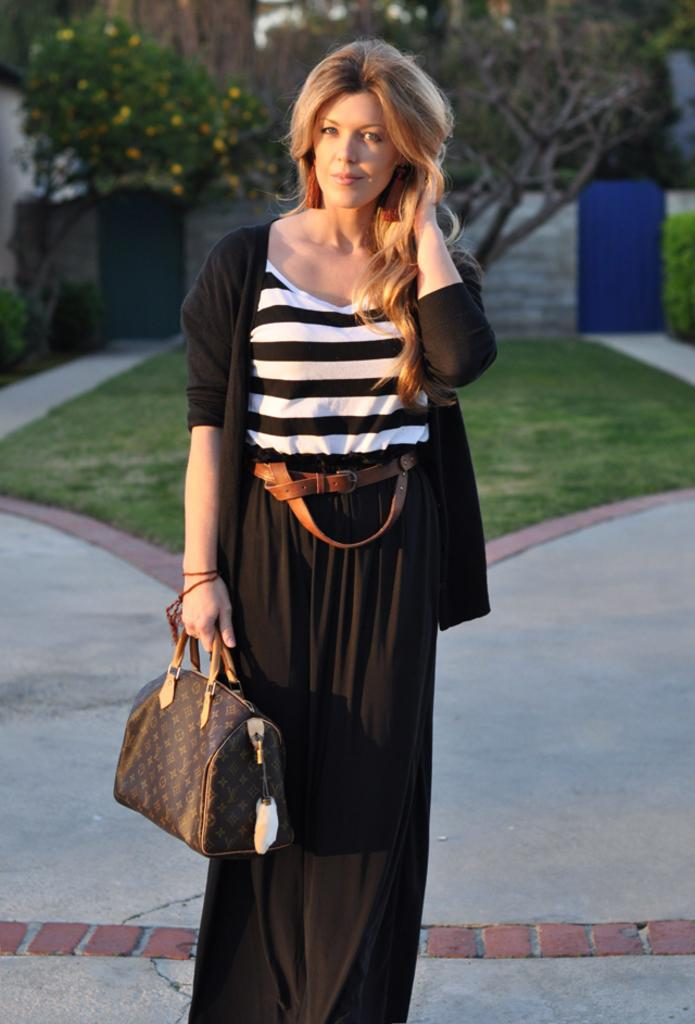Who is present in the image? There is a woman in the image. What is the woman wearing? The woman is wearing a black dress. What is the woman holding in the image? The woman is holding a bag. What can be seen in the background of the image? There are trees, plants, and green grass in the background of the image. What type of door can be seen in the image? There is no door present in the image. Is the scene taking place during the night in the image? The image does not provide any information about the time of day, so it cannot be determined if it is night or not. 